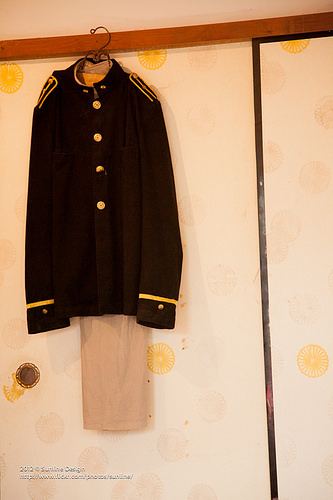<image>
Can you confirm if the wall is behind the shirt? Yes. From this viewpoint, the wall is positioned behind the shirt, with the shirt partially or fully occluding the wall. 